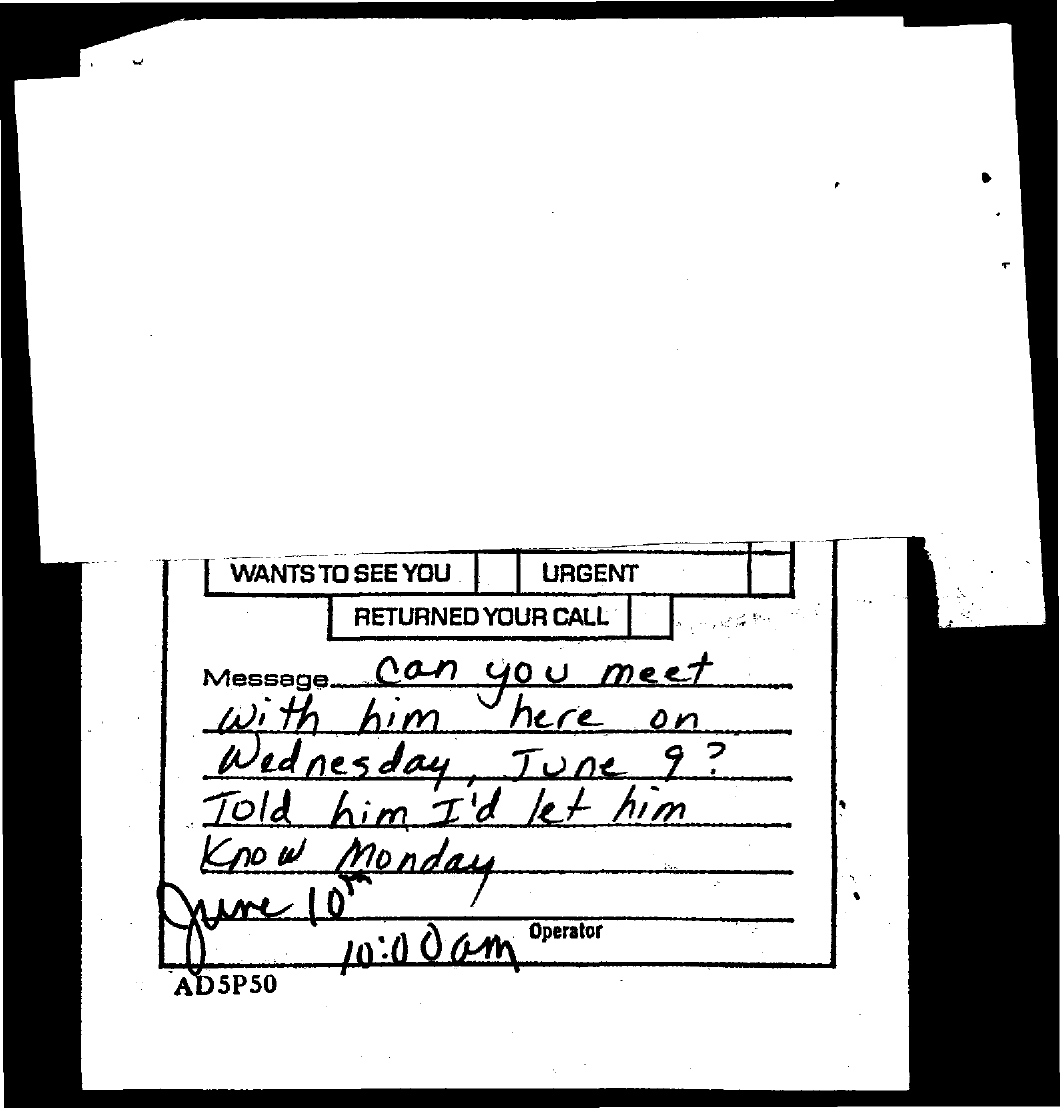What is the time mentioned in the document?
Provide a short and direct response. 10:00 am. 